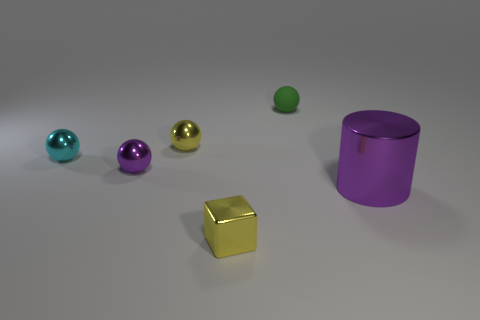What could be the purpose of this arrangement of objects? The arrangement of the objects in the image might be purely decorative or illustrative, possibly displaying a variety of colors and shapes for aesthetic or demonstration purposes, such as in a 3D modeling render or an artistic composition. 